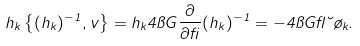Convert formula to latex. <formula><loc_0><loc_0><loc_500><loc_500>h _ { k } \left \{ ( h _ { k } ) ^ { - 1 } , v \right \} = h _ { k } 4 \pi G \frac { \partial } { \partial \beta } ( h _ { k } ) ^ { - 1 } = - 4 \pi G \gamma \lambda \tau _ { k } .</formula> 